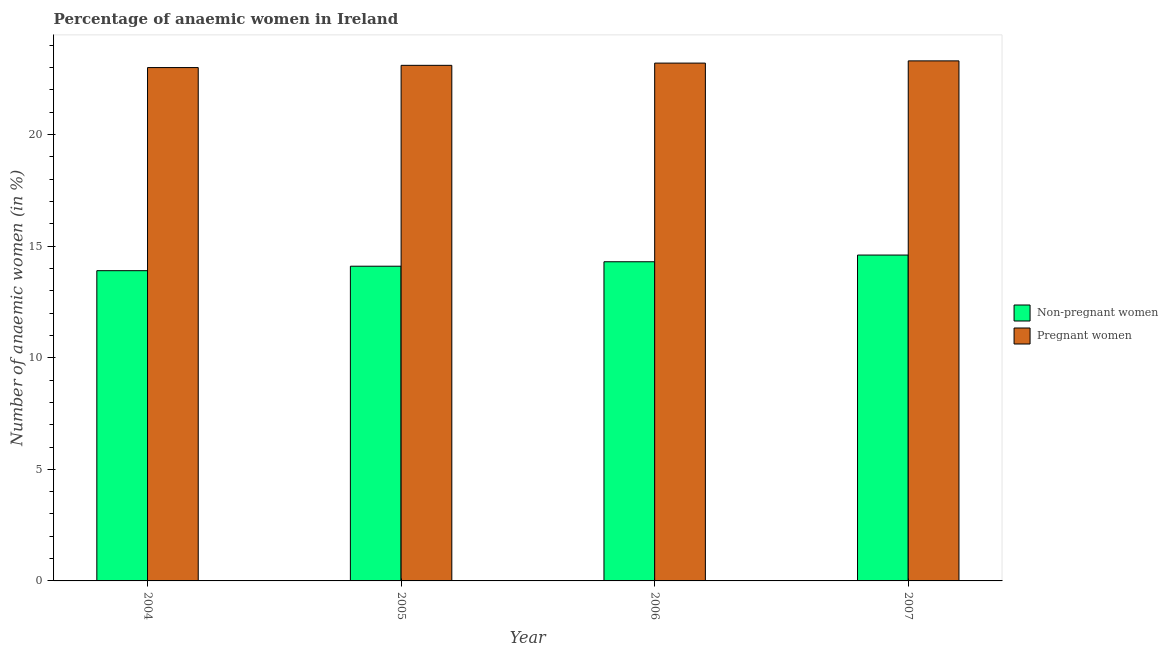How many different coloured bars are there?
Offer a terse response. 2. Are the number of bars per tick equal to the number of legend labels?
Offer a very short reply. Yes. How many bars are there on the 2nd tick from the right?
Make the answer very short. 2. What is the label of the 2nd group of bars from the left?
Make the answer very short. 2005. In how many cases, is the number of bars for a given year not equal to the number of legend labels?
Make the answer very short. 0. What is the percentage of pregnant anaemic women in 2006?
Your answer should be compact. 23.2. Across all years, what is the maximum percentage of pregnant anaemic women?
Your response must be concise. 23.3. In which year was the percentage of non-pregnant anaemic women minimum?
Provide a short and direct response. 2004. What is the total percentage of pregnant anaemic women in the graph?
Ensure brevity in your answer.  92.6. What is the difference between the percentage of pregnant anaemic women in 2004 and that in 2006?
Offer a terse response. -0.2. What is the average percentage of pregnant anaemic women per year?
Ensure brevity in your answer.  23.15. In the year 2006, what is the difference between the percentage of pregnant anaemic women and percentage of non-pregnant anaemic women?
Offer a terse response. 0. What is the ratio of the percentage of pregnant anaemic women in 2005 to that in 2007?
Ensure brevity in your answer.  0.99. Is the difference between the percentage of pregnant anaemic women in 2006 and 2007 greater than the difference between the percentage of non-pregnant anaemic women in 2006 and 2007?
Keep it short and to the point. No. What is the difference between the highest and the second highest percentage of pregnant anaemic women?
Ensure brevity in your answer.  0.1. What is the difference between the highest and the lowest percentage of pregnant anaemic women?
Ensure brevity in your answer.  0.3. What does the 2nd bar from the left in 2006 represents?
Your answer should be compact. Pregnant women. What does the 1st bar from the right in 2007 represents?
Offer a very short reply. Pregnant women. How many bars are there?
Keep it short and to the point. 8. How many years are there in the graph?
Provide a short and direct response. 4. What is the difference between two consecutive major ticks on the Y-axis?
Offer a very short reply. 5. Are the values on the major ticks of Y-axis written in scientific E-notation?
Your answer should be very brief. No. Does the graph contain grids?
Make the answer very short. No. Where does the legend appear in the graph?
Make the answer very short. Center right. How are the legend labels stacked?
Make the answer very short. Vertical. What is the title of the graph?
Your answer should be compact. Percentage of anaemic women in Ireland. What is the label or title of the X-axis?
Make the answer very short. Year. What is the label or title of the Y-axis?
Provide a succinct answer. Number of anaemic women (in %). What is the Number of anaemic women (in %) in Non-pregnant women in 2004?
Give a very brief answer. 13.9. What is the Number of anaemic women (in %) in Pregnant women in 2004?
Give a very brief answer. 23. What is the Number of anaemic women (in %) in Non-pregnant women in 2005?
Your answer should be very brief. 14.1. What is the Number of anaemic women (in %) of Pregnant women in 2005?
Your answer should be very brief. 23.1. What is the Number of anaemic women (in %) of Non-pregnant women in 2006?
Ensure brevity in your answer.  14.3. What is the Number of anaemic women (in %) of Pregnant women in 2006?
Keep it short and to the point. 23.2. What is the Number of anaemic women (in %) of Pregnant women in 2007?
Your response must be concise. 23.3. Across all years, what is the maximum Number of anaemic women (in %) of Non-pregnant women?
Make the answer very short. 14.6. Across all years, what is the maximum Number of anaemic women (in %) of Pregnant women?
Your response must be concise. 23.3. Across all years, what is the minimum Number of anaemic women (in %) in Non-pregnant women?
Give a very brief answer. 13.9. Across all years, what is the minimum Number of anaemic women (in %) in Pregnant women?
Your answer should be very brief. 23. What is the total Number of anaemic women (in %) of Non-pregnant women in the graph?
Your answer should be very brief. 56.9. What is the total Number of anaemic women (in %) in Pregnant women in the graph?
Provide a short and direct response. 92.6. What is the difference between the Number of anaemic women (in %) of Non-pregnant women in 2004 and that in 2005?
Offer a very short reply. -0.2. What is the difference between the Number of anaemic women (in %) of Pregnant women in 2004 and that in 2005?
Provide a succinct answer. -0.1. What is the difference between the Number of anaemic women (in %) in Pregnant women in 2004 and that in 2007?
Your response must be concise. -0.3. What is the difference between the Number of anaemic women (in %) of Non-pregnant women in 2005 and that in 2006?
Provide a short and direct response. -0.2. What is the difference between the Number of anaemic women (in %) in Pregnant women in 2005 and that in 2006?
Make the answer very short. -0.1. What is the difference between the Number of anaemic women (in %) of Non-pregnant women in 2005 and that in 2007?
Offer a terse response. -0.5. What is the difference between the Number of anaemic women (in %) of Pregnant women in 2005 and that in 2007?
Ensure brevity in your answer.  -0.2. What is the difference between the Number of anaemic women (in %) in Non-pregnant women in 2006 and that in 2007?
Keep it short and to the point. -0.3. What is the average Number of anaemic women (in %) of Non-pregnant women per year?
Ensure brevity in your answer.  14.22. What is the average Number of anaemic women (in %) of Pregnant women per year?
Your response must be concise. 23.15. In the year 2006, what is the difference between the Number of anaemic women (in %) of Non-pregnant women and Number of anaemic women (in %) of Pregnant women?
Ensure brevity in your answer.  -8.9. What is the ratio of the Number of anaemic women (in %) of Non-pregnant women in 2004 to that in 2005?
Ensure brevity in your answer.  0.99. What is the ratio of the Number of anaemic women (in %) of Pregnant women in 2004 to that in 2005?
Offer a terse response. 1. What is the ratio of the Number of anaemic women (in %) in Non-pregnant women in 2004 to that in 2006?
Your answer should be compact. 0.97. What is the ratio of the Number of anaemic women (in %) of Non-pregnant women in 2004 to that in 2007?
Offer a very short reply. 0.95. What is the ratio of the Number of anaemic women (in %) in Pregnant women in 2004 to that in 2007?
Your answer should be compact. 0.99. What is the ratio of the Number of anaemic women (in %) of Non-pregnant women in 2005 to that in 2006?
Make the answer very short. 0.99. What is the ratio of the Number of anaemic women (in %) of Pregnant women in 2005 to that in 2006?
Give a very brief answer. 1. What is the ratio of the Number of anaemic women (in %) in Non-pregnant women in 2005 to that in 2007?
Your response must be concise. 0.97. What is the ratio of the Number of anaemic women (in %) of Non-pregnant women in 2006 to that in 2007?
Provide a succinct answer. 0.98. What is the ratio of the Number of anaemic women (in %) in Pregnant women in 2006 to that in 2007?
Ensure brevity in your answer.  1. What is the difference between the highest and the second highest Number of anaemic women (in %) in Non-pregnant women?
Offer a very short reply. 0.3. What is the difference between the highest and the lowest Number of anaemic women (in %) in Pregnant women?
Keep it short and to the point. 0.3. 